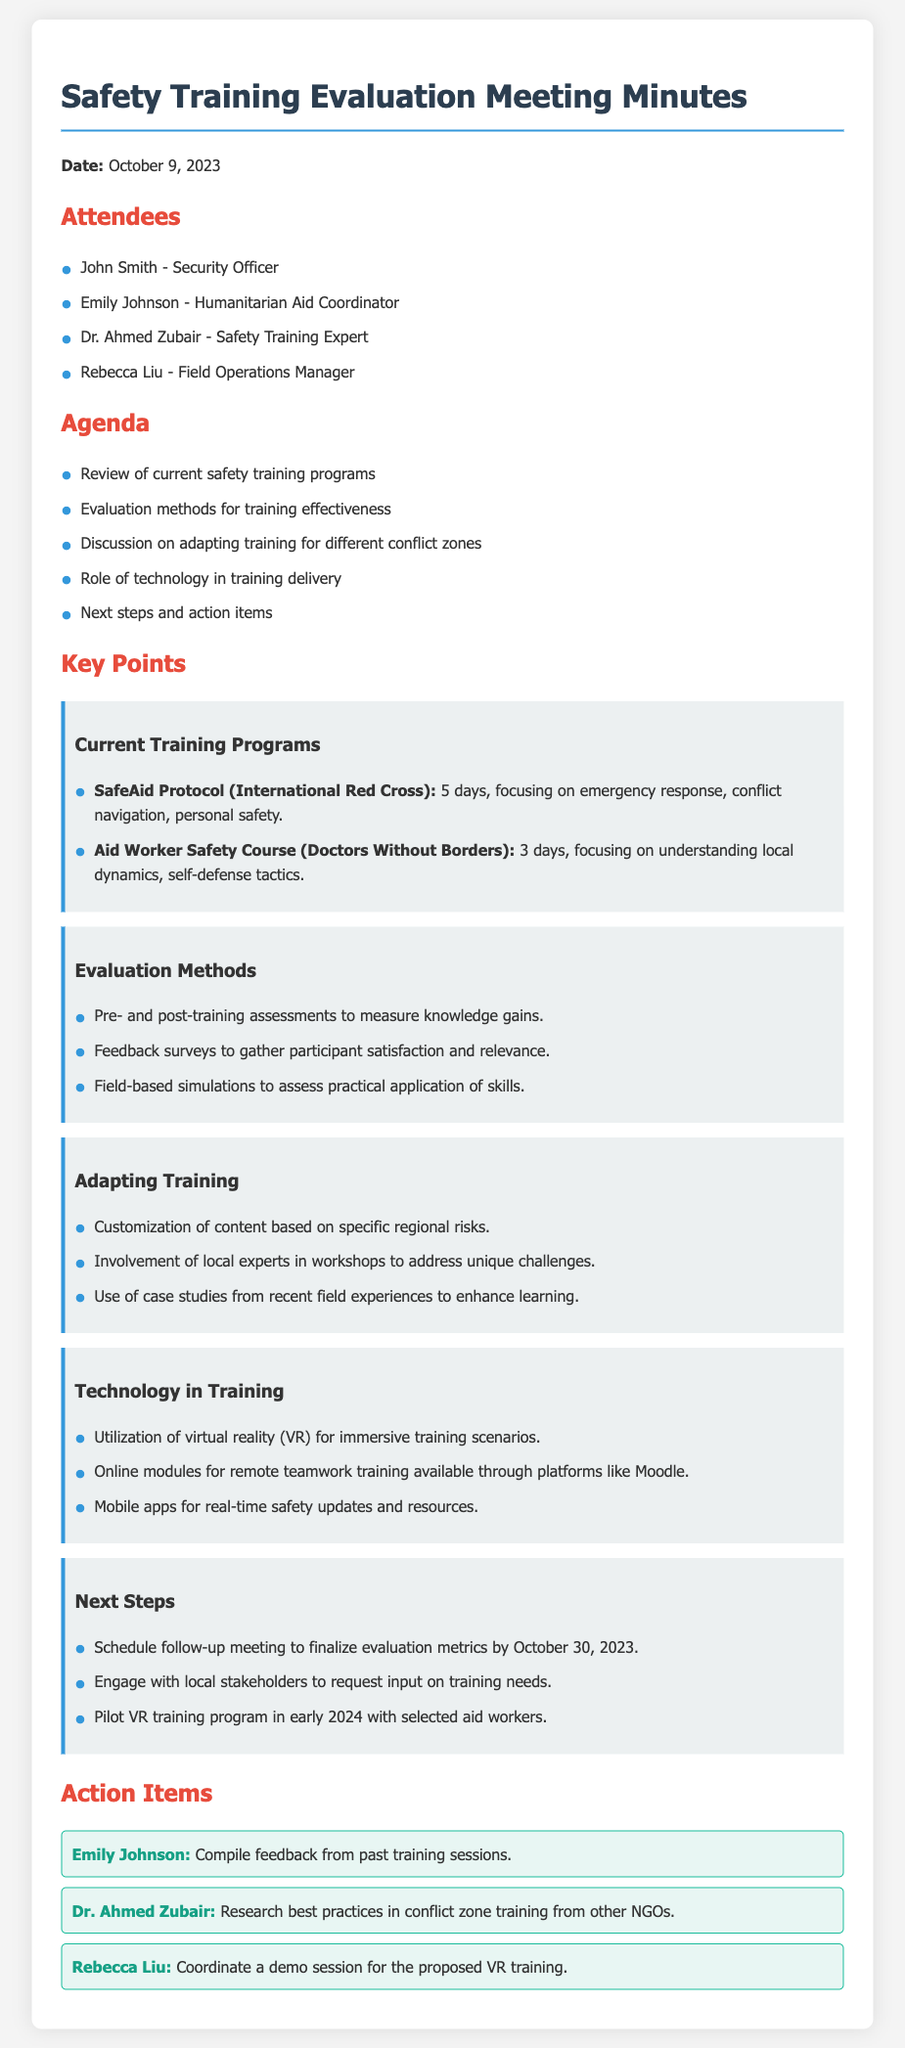what is the date of the meeting? The date of the meeting is explicitly mentioned at the beginning of the document.
Answer: October 9, 2023 who was the Security Officer at the meeting? The document lists attendees, highlighting their roles, including the Security Officer.
Answer: John Smith how many training days does the SafeAid Protocol consist of? The document provides detailed information about current training programs, including their duration.
Answer: 5 days what is one method used for evaluating training effectiveness? The document outlines various evaluation methods used to assess training effectiveness.
Answer: Pre- and post-training assessments who is responsible for compiling feedback from past training sessions? The action items section specifies responsibilities assigned to attendees.
Answer: Emily Johnson which program focuses on understanding local dynamics? The document describes current training programs and their specific focuses.
Answer: Aid Worker Safety Course what technology is utilized for immersive training scenarios? The document mentions the use of technology in training, specifying a particular technology.
Answer: Virtual reality (VR) when should the follow-up meeting to finalize evaluation metrics be scheduled? The timeline for the next steps includes a specific date for the follow-up meeting.
Answer: October 30, 2023 